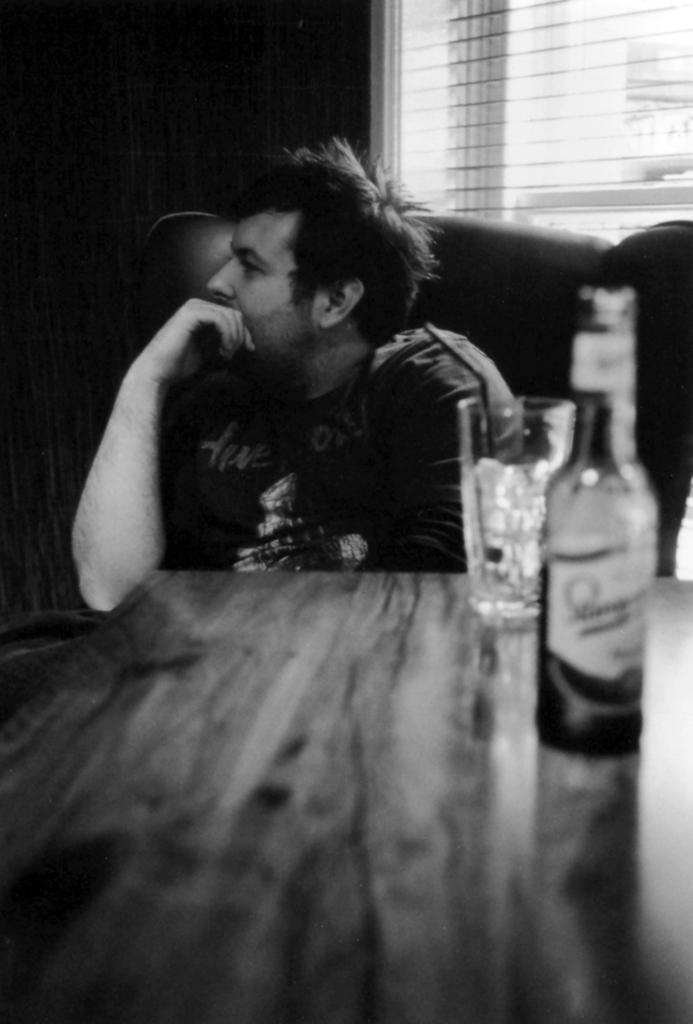Who is present in the image? There is a man in the image. What is the man doing in the image? The man is sitting in a chair. Where is the chair located in relation to the table? The chair is in front of a table. What items can be seen on the table? There is a glass and a wine bottle on the table. What is visible in the background of the image? There is a window in the background of the image. What type of paper is the girl reading in the image? There is no girl or paper present in the image; it features a man sitting in a chair in front of a table with a glass and a wine bottle. 